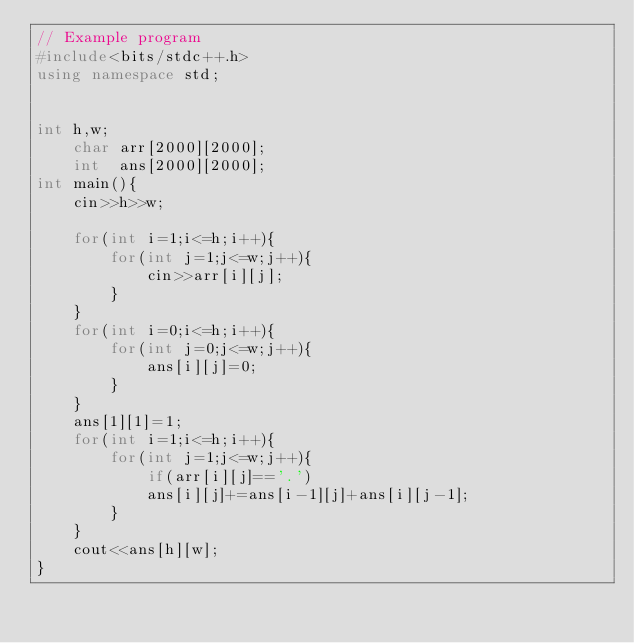<code> <loc_0><loc_0><loc_500><loc_500><_C++_>// Example program
#include<bits/stdc++.h>
using namespace std;


int h,w;
	char arr[2000][2000];
	int  ans[2000][2000];
int main(){
	cin>>h>>w;

	for(int i=1;i<=h;i++){
		for(int j=1;j<=w;j++){
			cin>>arr[i][j];
		}
	}
	for(int i=0;i<=h;i++){
		for(int j=0;j<=w;j++){
			ans[i][j]=0;
		}
	}
	ans[1][1]=1;
	for(int i=1;i<=h;i++){
		for(int j=1;j<=w;j++){
			if(arr[i][j]=='.')
			ans[i][j]+=ans[i-1][j]+ans[i][j-1];
		}
	}
	cout<<ans[h][w];
}
</code> 